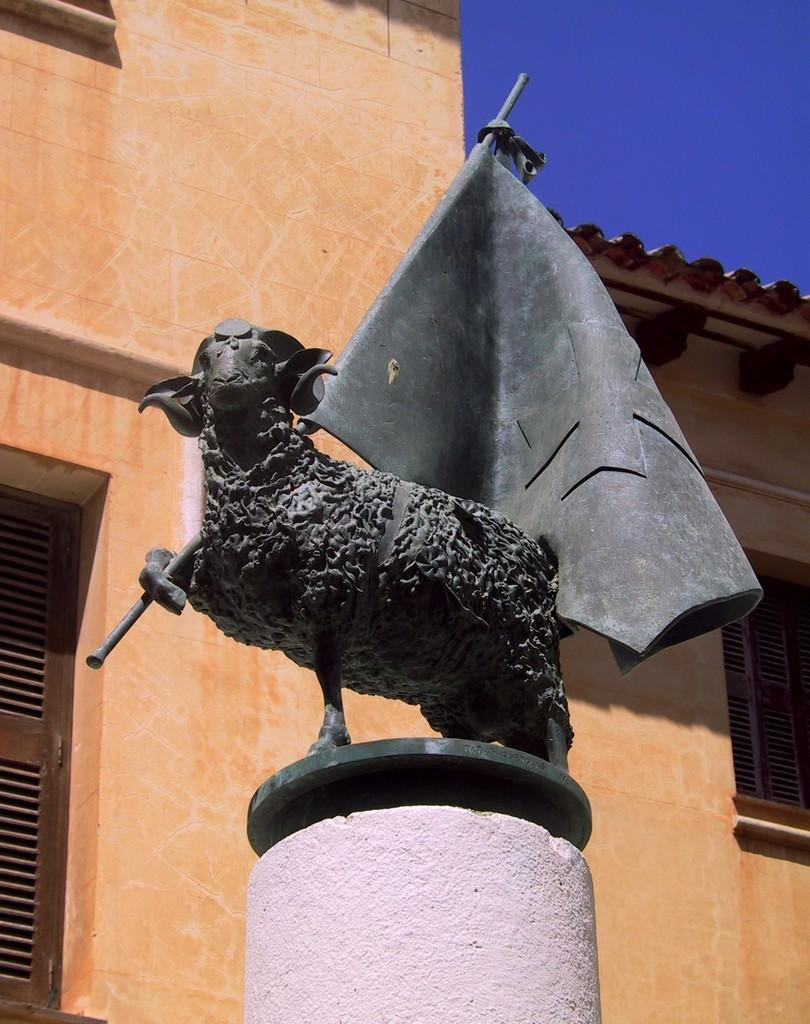What type of artwork is present in the image? There is a sculpture of an animal in the image. What type of structure can be seen in the image? There is a building in the image. What architectural feature is visible on the building? There are windows visible in the image. What is visible in the background of the image? The sky is visible in the image. What type of soup is being served in the image? There is no soup present in the image; it features a sculpture of an animal, a building, windows, and the sky. What advice might the mother give to her child in the image? There is no mother or child present in the image; it only contains a sculpture of an animal, a building, windows, and the sky. 